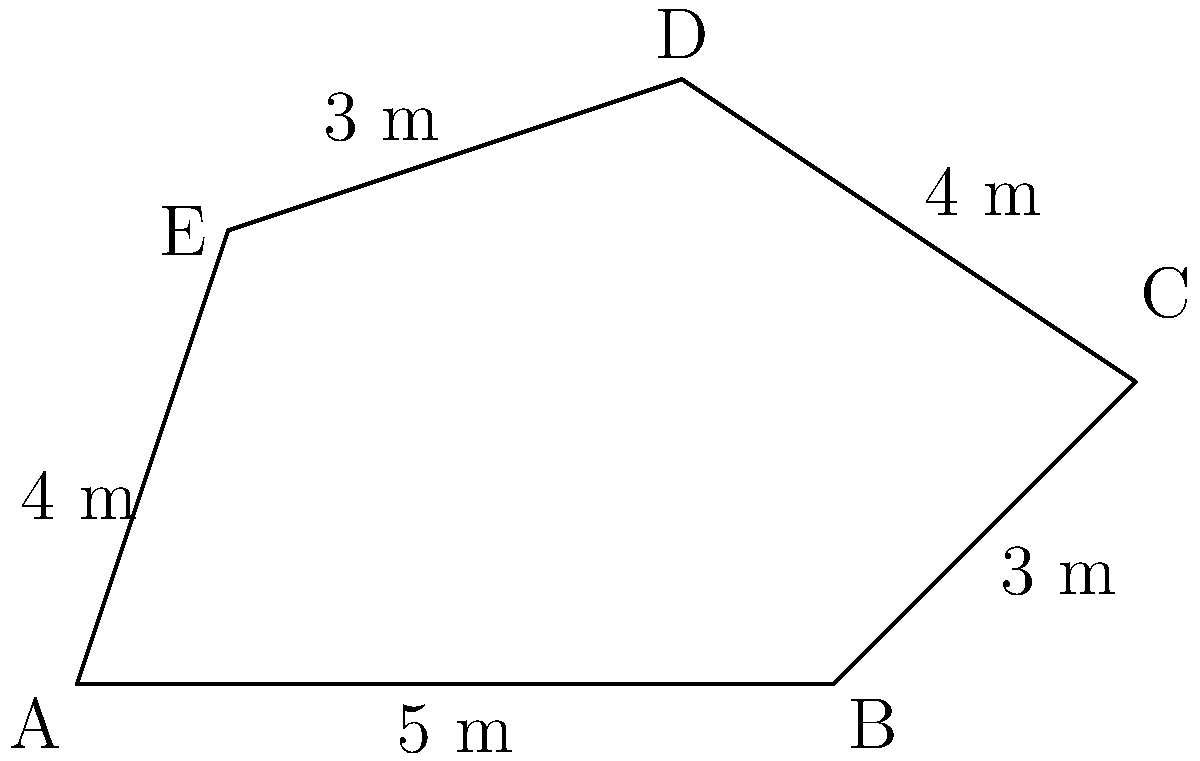You are leading a geological tour in Olduvai Gorge, Tanzania, and come across an irregular-shaped rock formation. The formation's perimeter needs to be calculated for a research project. Given the measurements shown in the diagram (in meters), what is the total perimeter of this geological formation? To calculate the perimeter of the irregular-shaped geological formation, we need to add up the lengths of all sides. Let's go through this step-by-step:

1. Identify the lengths of each side:
   - Side AB = 5 m
   - Side BC = 3 m
   - Side CD = 4 m
   - Side DE = 3 m
   - Side EA = 4 m

2. Add up all the side lengths:
   $$ \text{Perimeter} = AB + BC + CD + DE + EA $$
   $$ \text{Perimeter} = 5 + 3 + 4 + 3 + 4 $$
   $$ \text{Perimeter} = 19 \text{ m} $$

Therefore, the total perimeter of the geological formation is 19 meters.
Answer: 19 m 